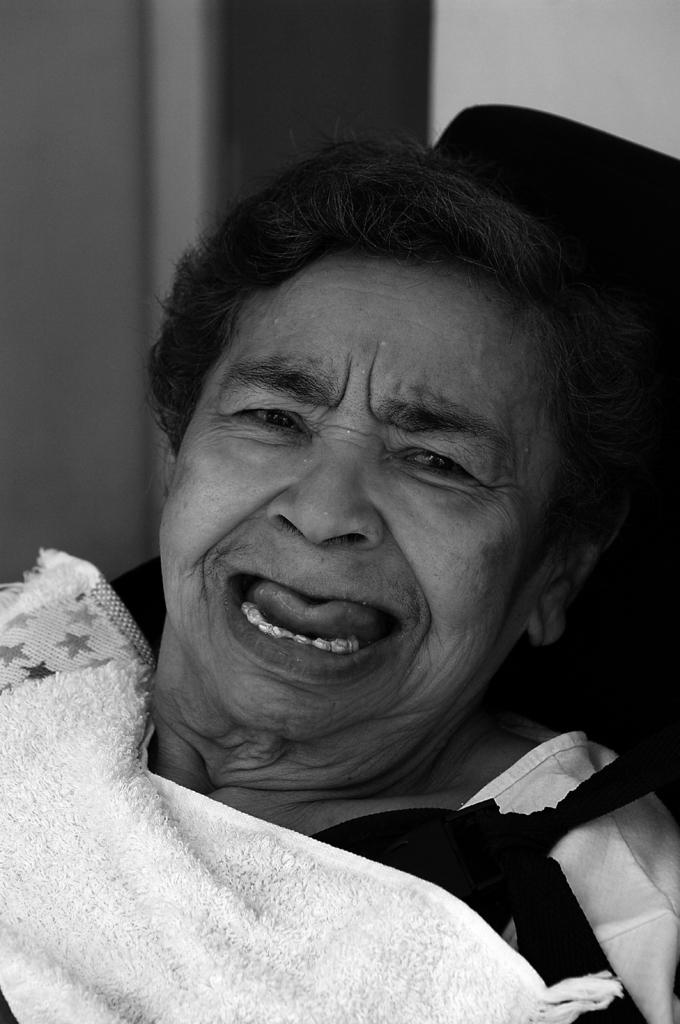What is the color scheme of the image? The image is black and white. What is the main subject of the image? There is a woman in the image. What type of nut can be seen in the woman's hand in the image? There is no nut present in the image, and the woman's hand is not visible. What riddle is the woman trying to solve in the image? There is no riddle present in the image; the woman is not depicted as solving a riddle. 